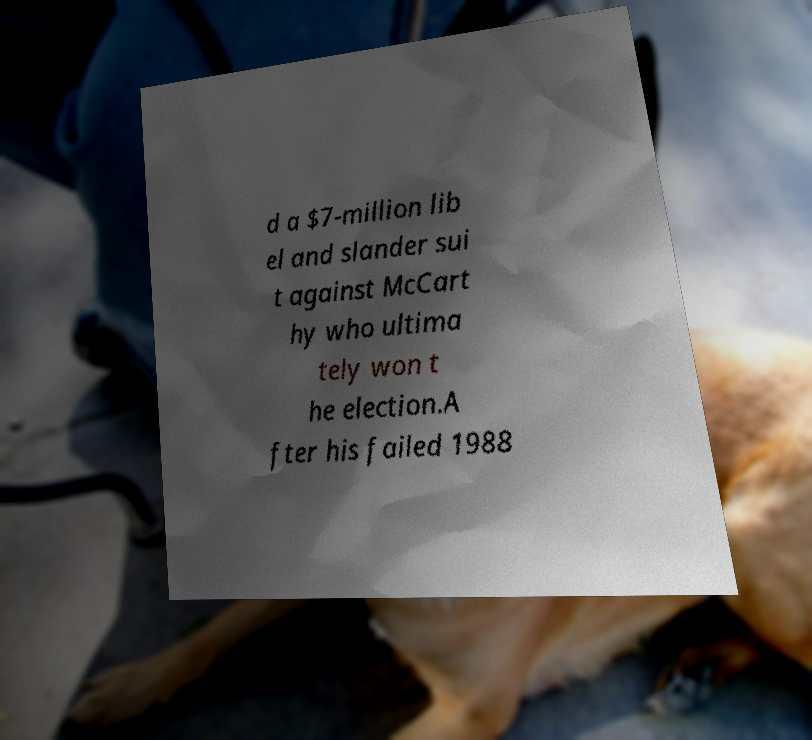What messages or text are displayed in this image? I need them in a readable, typed format. d a $7-million lib el and slander sui t against McCart hy who ultima tely won t he election.A fter his failed 1988 